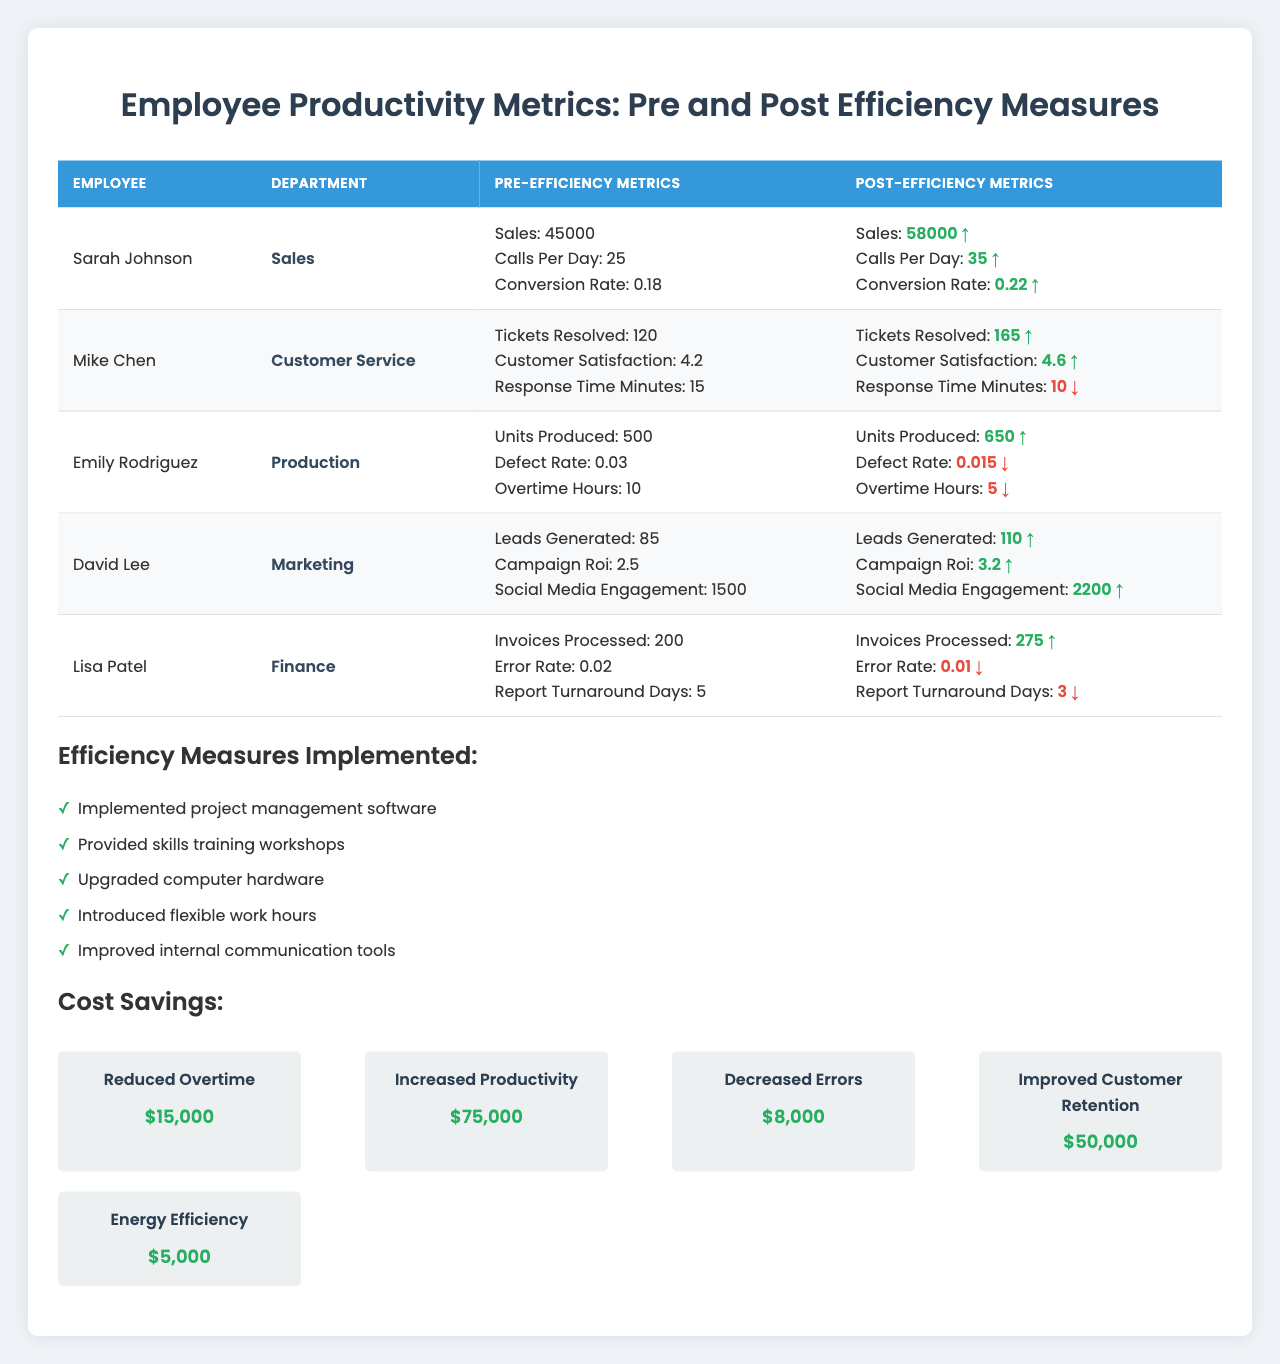What was Sarah Johnson's pre-efficiency sales figure? Sarah Johnson's pre-efficiency sales figure is directly listed in the table as 45000.
Answer: 45000 How many tickets did Mike Chen resolve post-efficiency measures? The table indicates that Mike Chen resolved 165 tickets after the efficiency measures were implemented.
Answer: 165 Which department had the highest increase in customer satisfaction? Mike Chen's customer satisfaction improved from 4.2 to 4.6, showing a 0.4 increase which is the highest among all departments.
Answer: Customer Service What is the percentage increase in Sarah Johnson's conversion rate? To find the percentage increase, subtract the pre-efficiency rate (0.18) from the post-efficiency rate (0.22) to get 0.04, then divide by the pre-efficiency rate (0.18) and multiply by 100: (0.04 / 0.18) * 100 ≈ 22.22%.
Answer: Approximately 22.22% Did Emily Rodriguez's defect rate improve? Yes, the defect rate decreased from 0.03 to 0.015, indicating an improvement.
Answer: Yes Compute the total pre-efficiency invoices processed by Lisa Patel and Emily Rodriguez. Lisa Patel processed 200 invoices, and Emily Rodriguez's data is not related, but if we only consider Lisa Patel, then it is 200.
Answer: 200 Which employee had the largest revenue increase in sales after implementing efficiency measures? Sarah Johnson had the largest increase in sales from 45000 to 58000, an increase of 13000.
Answer: Sarah Johnson Are all departments showing improvement in their metrics? Yes, all departments show positive changes in their respective metrics post-efficiency measures.
Answer: Yes What is the total cost saving achieved from increased productivity? The cost saving from increased productivity is listed as 75000.
Answer: 75000 How many more units did Emily Rodriguez produce post-efficiency measures compared to pre-efficiency? Emily Rodriguez produced 650 units post-efficiency compared to 500 pre-efficiency, thus producing 150 more units.
Answer: 150 